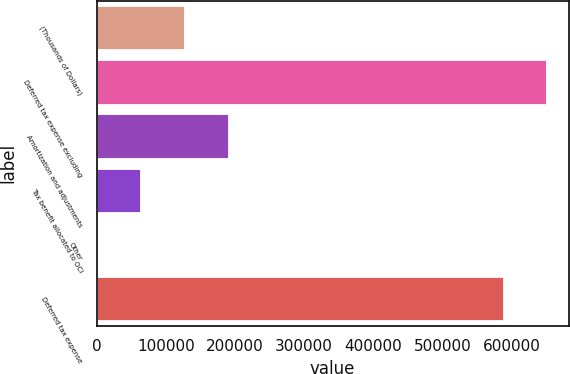Convert chart. <chart><loc_0><loc_0><loc_500><loc_500><bar_chart><fcel>(Thousands of Dollars)<fcel>Deferred tax expense excluding<fcel>Amortization and adjustments<fcel>Tax benefit allocated to OCI<fcel>Other<fcel>Deferred tax expense<nl><fcel>126179<fcel>649737<fcel>189266<fcel>63091.3<fcel>4<fcel>586650<nl></chart> 